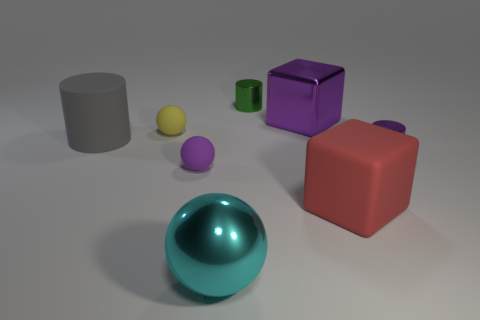Add 1 large purple matte cylinders. How many objects exist? 9 Subtract all balls. How many objects are left? 5 Subtract all yellow metal things. Subtract all tiny yellow matte things. How many objects are left? 7 Add 7 tiny purple cylinders. How many tiny purple cylinders are left? 8 Add 1 tiny shiny cylinders. How many tiny shiny cylinders exist? 3 Subtract 0 brown balls. How many objects are left? 8 